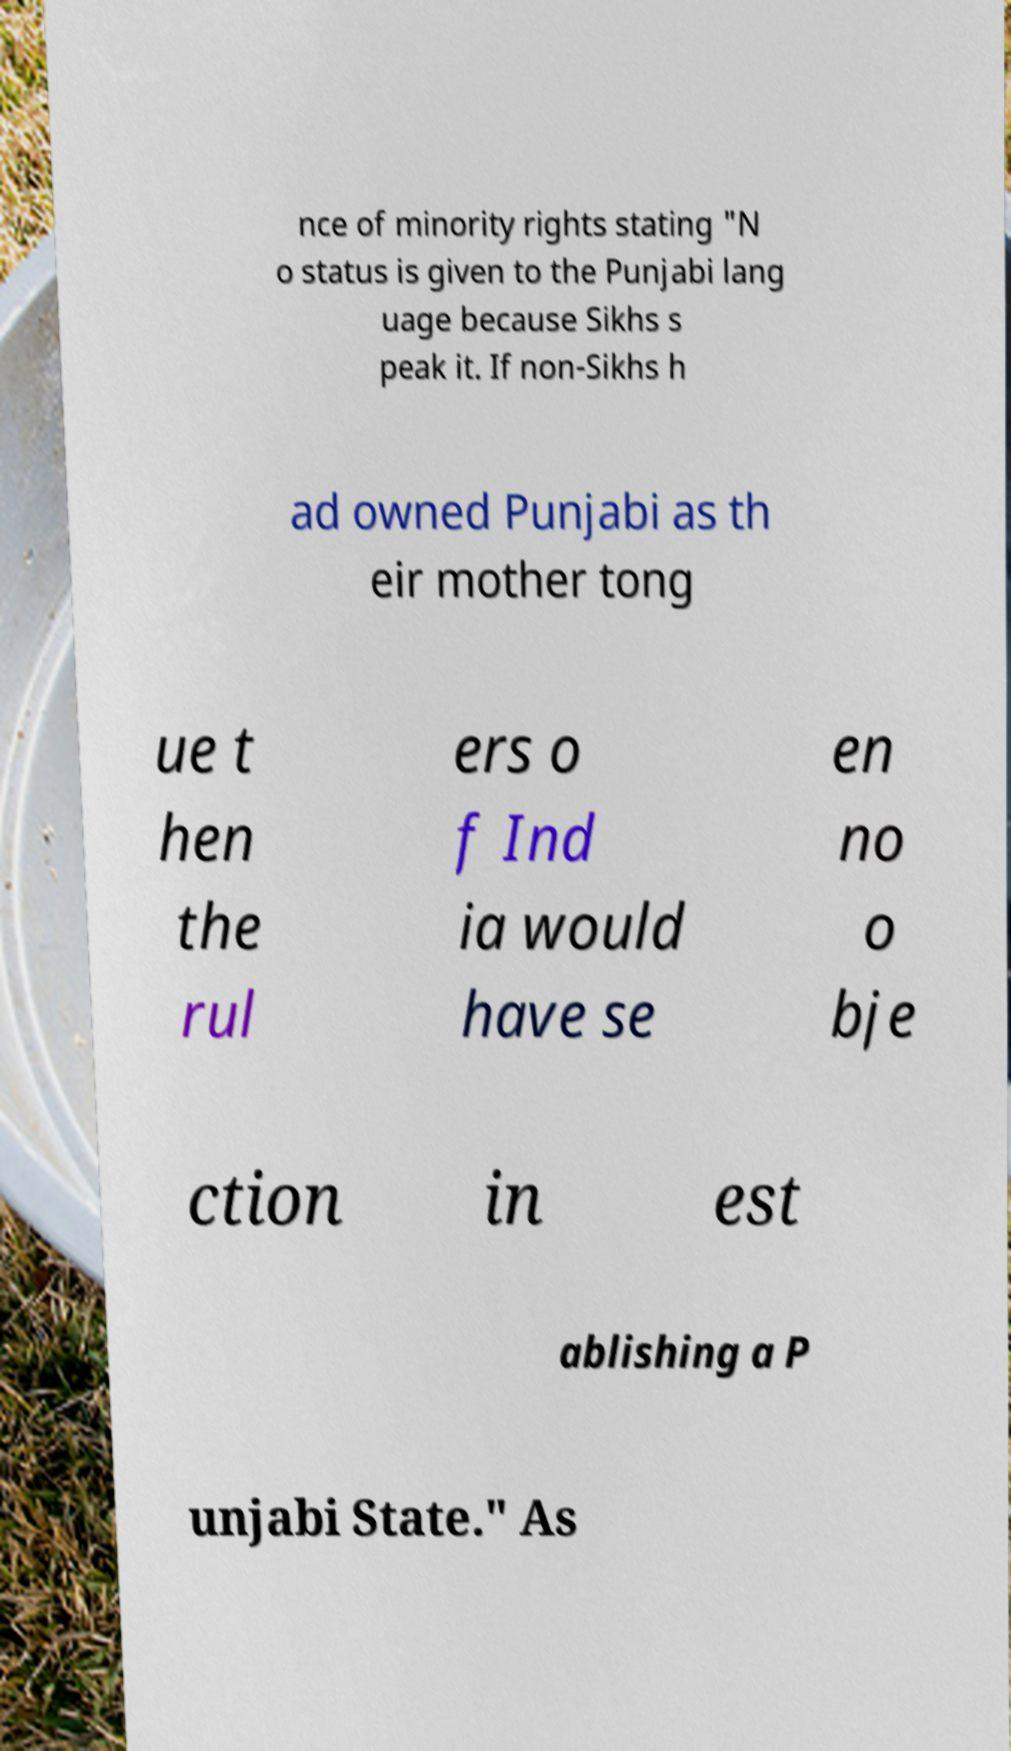Can you read and provide the text displayed in the image?This photo seems to have some interesting text. Can you extract and type it out for me? nce of minority rights stating "N o status is given to the Punjabi lang uage because Sikhs s peak it. If non-Sikhs h ad owned Punjabi as th eir mother tong ue t hen the rul ers o f Ind ia would have se en no o bje ction in est ablishing a P unjabi State." As 